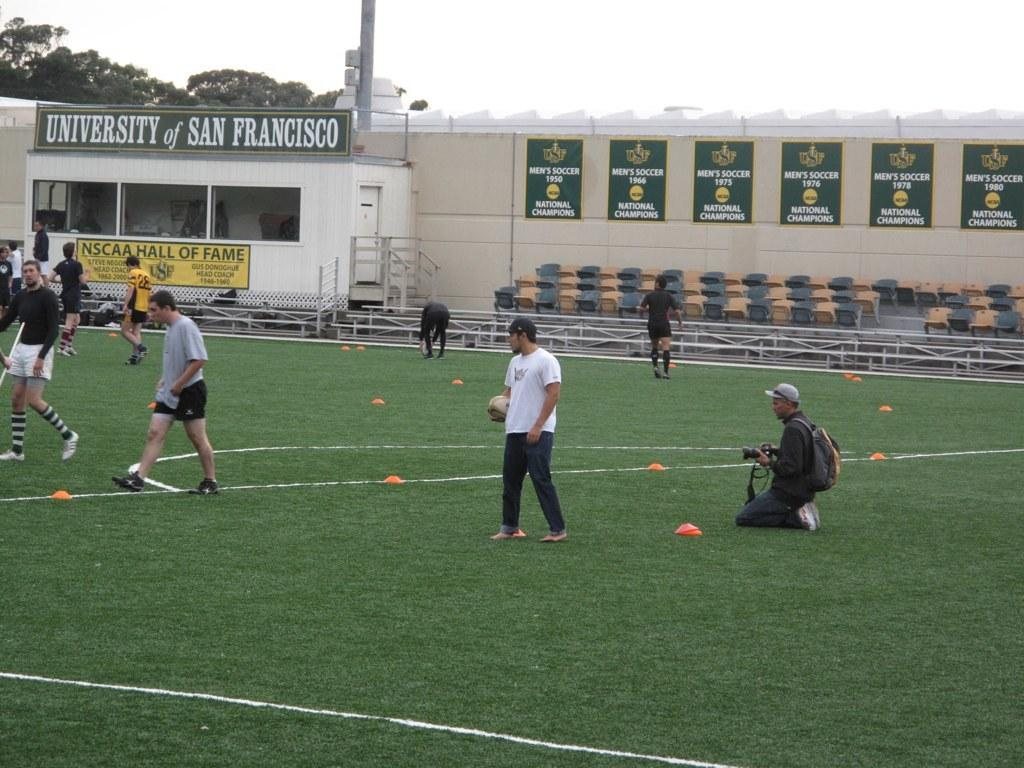<image>
Present a compact description of the photo's key features. Men are on a soccer field at the University of San Francisco practicing soccer drills. 